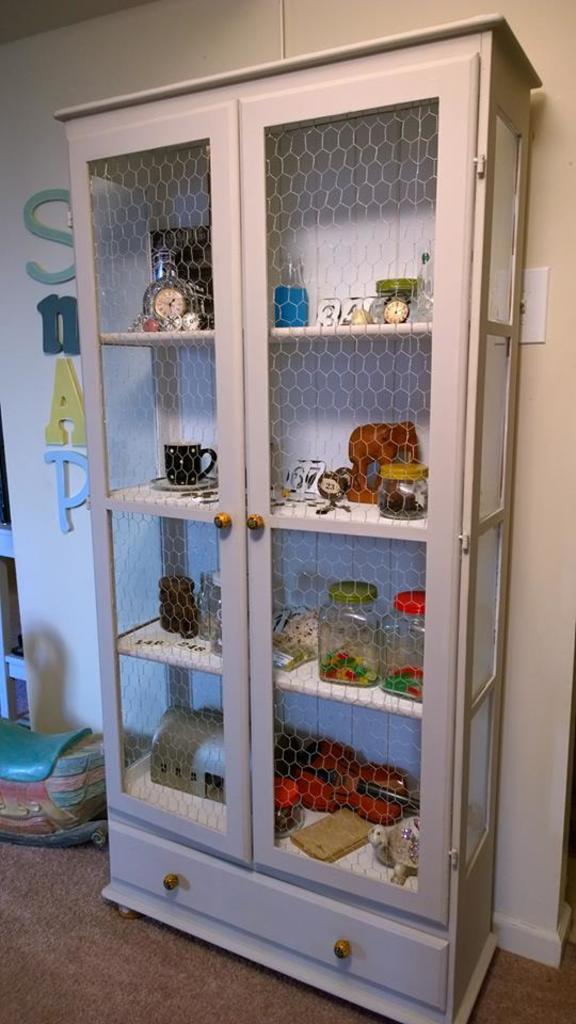What can be seen in the image that is used for storage or display? There is a shelf in the image that is used for storage or display. What is placed on the shelf in the image? There are objects placed on the shelf in the image. What is visible behind the shelf in the image? There is a wall visible behind the shelf in the image. What type of treatment is being administered to the objects on the shelf in the image? There is no treatment being administered to the objects on the shelf in the image; they are simply placed there for storage or display. 